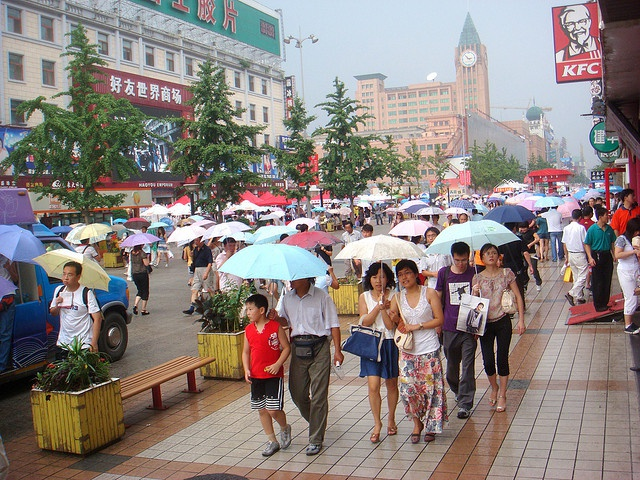Describe the objects in this image and their specific colors. I can see people in gray, black, lightgray, darkgray, and brown tones, potted plant in gray, black, olive, and maroon tones, umbrella in gray, white, darkgray, and lightblue tones, people in gray, brown, darkgray, lightgray, and maroon tones, and people in gray, black, darkgray, and maroon tones in this image. 